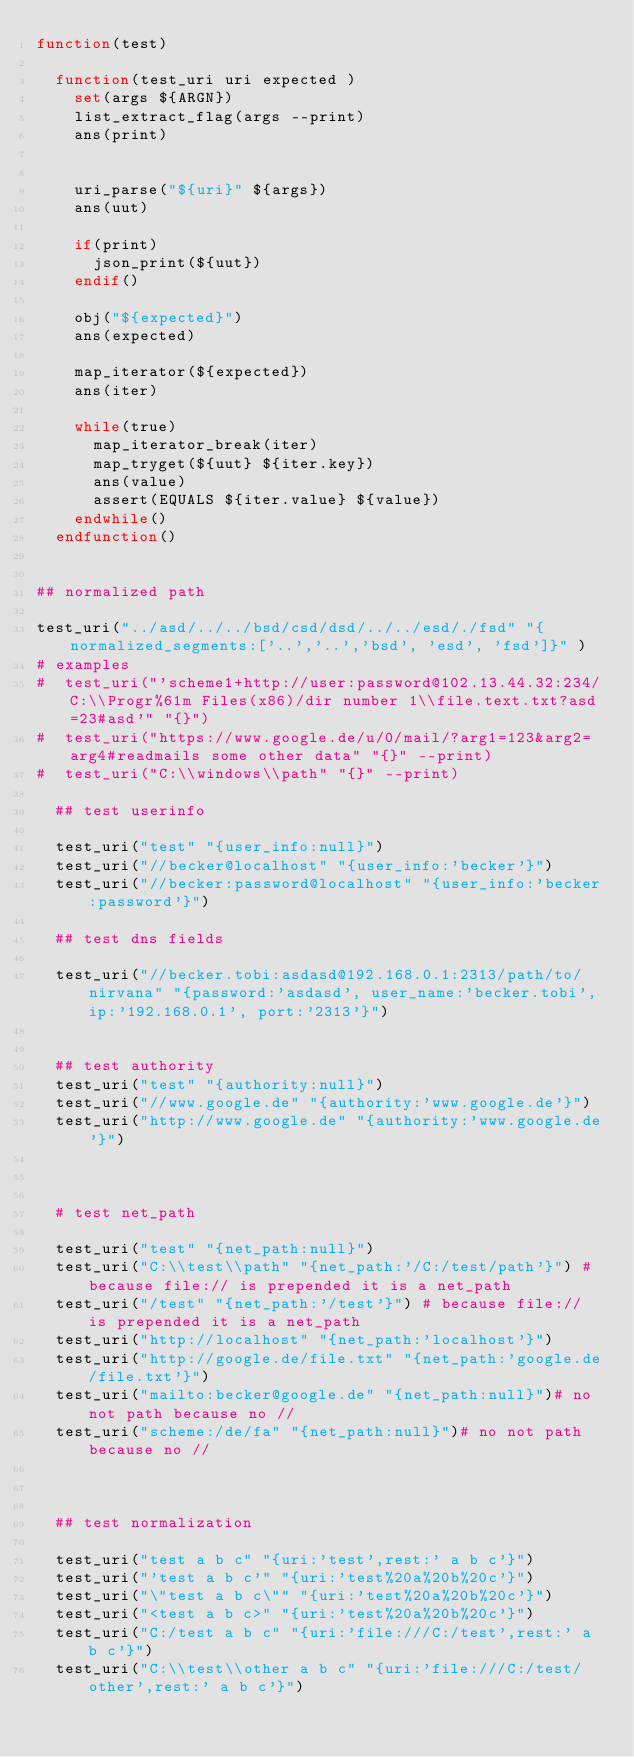<code> <loc_0><loc_0><loc_500><loc_500><_CMake_>function(test)

  function(test_uri uri expected )
    set(args ${ARGN})
    list_extract_flag(args --print)
    ans(print)


    uri_parse("${uri}" ${args})
    ans(uut)
    
    if(print)
      json_print(${uut})
    endif()

    obj("${expected}")
    ans(expected)

    map_iterator(${expected})
    ans(iter)

    while(true)
      map_iterator_break(iter)
      map_tryget(${uut} ${iter.key})
      ans(value)
      assert(EQUALS ${iter.value} ${value})
    endwhile()
  endfunction()


## normalized path

test_uri("../asd/../../bsd/csd/dsd/../../esd/./fsd" "{normalized_segments:['..','..','bsd', 'esd', 'fsd']}" )
# examples
#  test_uri("'scheme1+http://user:password@102.13.44.32:234/C:\\Progr%61m Files(x86)/dir number 1\\file.text.txt?asd=23#asd'" "{}")
#  test_uri("https://www.google.de/u/0/mail/?arg1=123&arg2=arg4#readmails some other data" "{}" --print)
#  test_uri("C:\\windows\\path" "{}" --print)

  ## test userinfo

  test_uri("test" "{user_info:null}")
  test_uri("//becker@localhost" "{user_info:'becker'}")
  test_uri("//becker:password@localhost" "{user_info:'becker:password'}")
  
  ## test dns fields

  test_uri("//becker.tobi:asdasd@192.168.0.1:2313/path/to/nirvana" "{password:'asdasd', user_name:'becker.tobi', ip:'192.168.0.1', port:'2313'}") 


  ## test authority
  test_uri("test" "{authority:null}")
  test_uri("//www.google.de" "{authority:'www.google.de'}")
  test_uri("http://www.google.de" "{authority:'www.google.de'}")


  
  # test net_path

  test_uri("test" "{net_path:null}")
  test_uri("C:\\test\\path" "{net_path:'/C:/test/path'}") # because file:// is prepended it is a net_path
  test_uri("/test" "{net_path:'/test'}") # because file:// is prepended it is a net_path
  test_uri("http://localhost" "{net_path:'localhost'}")
  test_uri("http://google.de/file.txt" "{net_path:'google.de/file.txt'}")
  test_uri("mailto:becker@google.de" "{net_path:null}")# no not path because no //
  test_uri("scheme:/de/fa" "{net_path:null}")# no not path because no //


  
  ## test normalization

  test_uri("test a b c" "{uri:'test',rest:' a b c'}")
  test_uri("'test a b c'" "{uri:'test%20a%20b%20c'}")
  test_uri("\"test a b c\"" "{uri:'test%20a%20b%20c'}")
  test_uri("<test a b c>" "{uri:'test%20a%20b%20c'}")
  test_uri("C:/test a b c" "{uri:'file:///C:/test',rest:' a b c'}")
  test_uri("C:\\test\\other a b c" "{uri:'file:///C:/test/other',rest:' a b c'}")</code> 